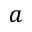Convert formula to latex. <formula><loc_0><loc_0><loc_500><loc_500>a</formula> 